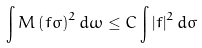<formula> <loc_0><loc_0><loc_500><loc_500>\int M \left ( f \sigma \right ) ^ { 2 } d \omega \leq C \int \left | f \right | ^ { 2 } d \sigma</formula> 